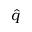Convert formula to latex. <formula><loc_0><loc_0><loc_500><loc_500>\hat { q }</formula> 